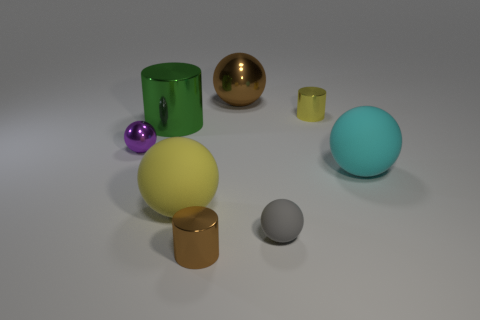There is a big metal sphere; does it have the same color as the tiny shiny cylinder that is in front of the big shiny cylinder?
Your answer should be compact. Yes. What shape is the brown shiny object that is in front of the rubber sphere behind the large yellow thing?
Keep it short and to the point. Cylinder. There is a small thing that is both on the right side of the small brown object and in front of the tiny purple shiny sphere; what is its shape?
Make the answer very short. Sphere. How many things are either small blue rubber objects or shiny balls behind the yellow metallic thing?
Your answer should be compact. 1. There is a large brown thing that is the same shape as the big yellow rubber thing; what is it made of?
Make the answer very short. Metal. There is a object that is in front of the purple thing and to the right of the gray ball; what material is it?
Offer a very short reply. Rubber. What number of tiny purple metal objects have the same shape as the gray thing?
Offer a terse response. 1. What is the color of the big object in front of the large sphere that is on the right side of the big brown metallic object?
Give a very brief answer. Yellow. Are there the same number of big balls that are to the left of the tiny gray object and small green objects?
Your answer should be compact. No. Are there any metal spheres that have the same size as the brown cylinder?
Offer a terse response. Yes. 